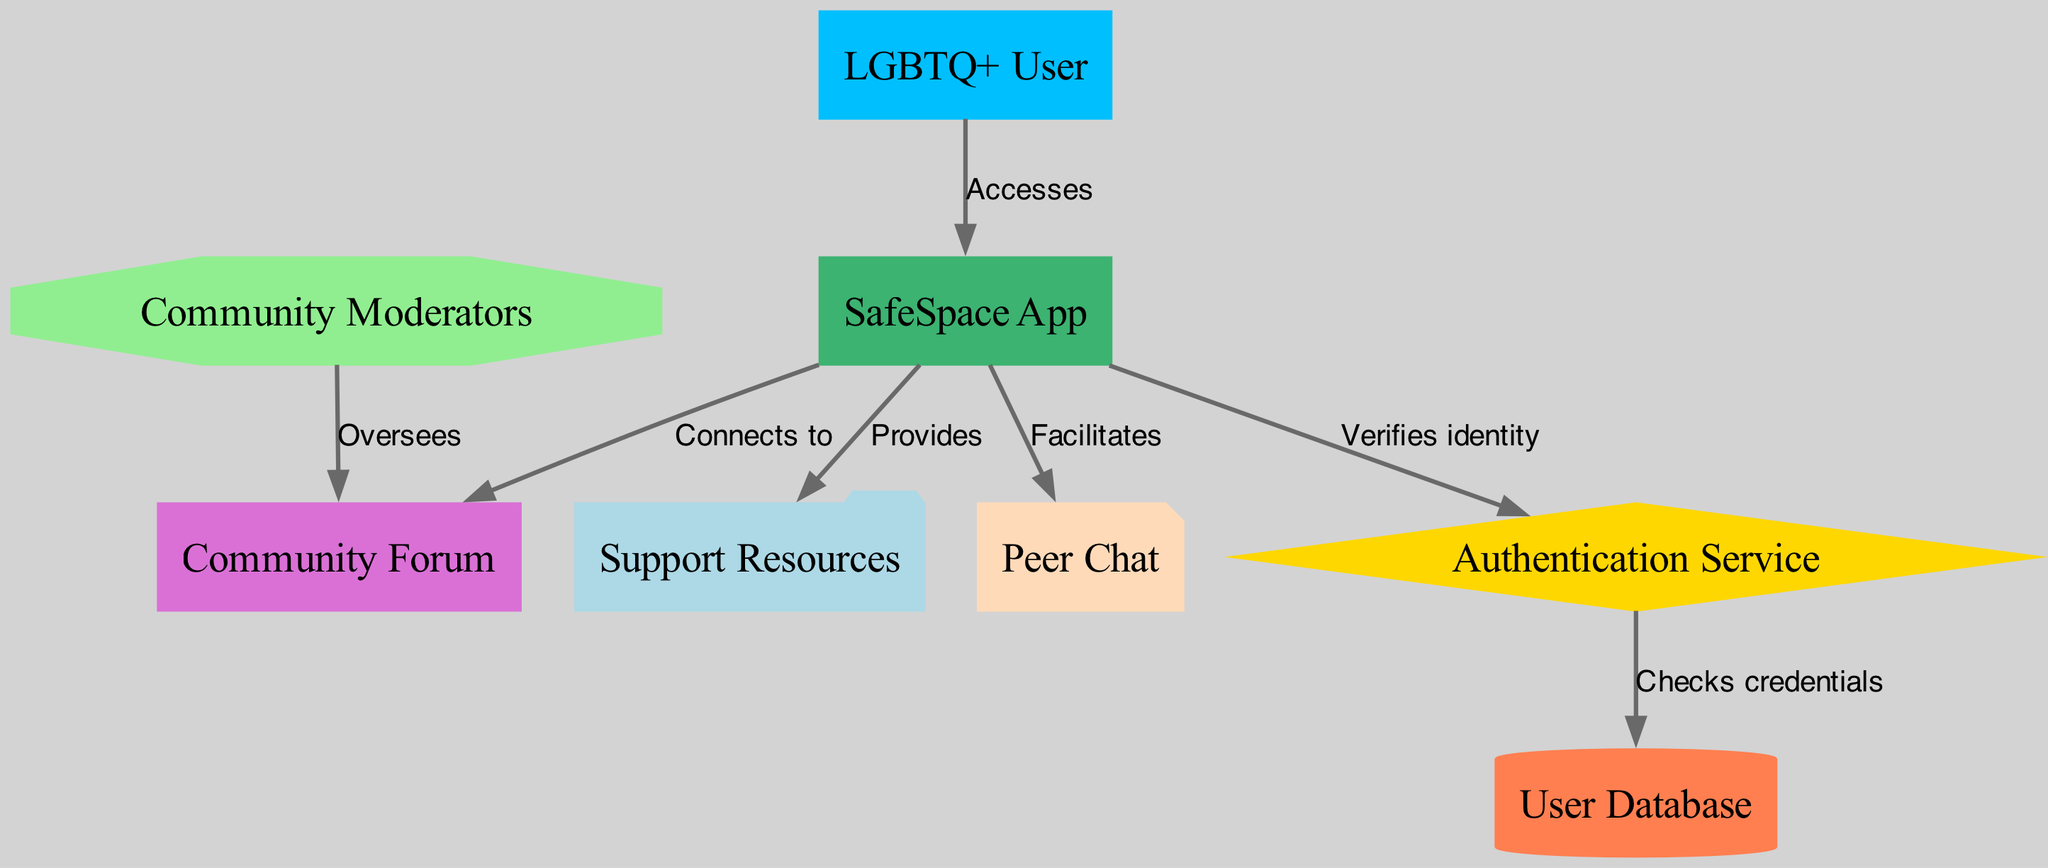What is the total number of nodes in the diagram? The diagram contains 8 nodes: LGBTQ+ User, SafeSpace App, Authentication Service, User Database, Community Forum, Support Resources, Peer Chat, and Community Moderators.
Answer: 8 Which service verifies the identity of the user? The arrow pointing from the SafeSpace App to the Authentication Service indicates that the SafeSpace App is responsible for verifying the user's identity.
Answer: Authentication Service Who oversees the Community Forum? The edge from Community Moderators to Community Forum shows that the Community Moderators are the ones overseeing the forum.
Answer: Community Moderators How does the app connect to the Community Forum? There is a direct edge marked "Connects to" from the SafeSpace App to the Community Forum, indicating the app's connection to the forum.
Answer: Connects to What action is facilitated by the SafeSpace App related to peer communication? The diagram shows an edge labeled "Facilitates" from the SafeSpace App to Peer Chat, signifying that the app facilitates peer communication through chat.
Answer: Peer Chat Which component checks user credentials? The flow moves from the Authentication Service to the User Database, indicating that the Authentication Service checks the user's credentials against the database.
Answer: User Database What is the shape of the Peer Chat node in the diagram? The Peer Chat node is represented as a note shape, as described in the node styles in the diagram.
Answer: Note What color represents the Authentication Service in the diagram? The Authentication Service is colored gold in the diagram, according to the specified node styles.
Answer: Gold 